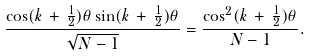<formula> <loc_0><loc_0><loc_500><loc_500>\frac { \cos ( k \, + \, \frac { 1 } { 2 } ) \theta \sin ( k \, + \, \frac { 1 } { 2 } ) \theta } { \sqrt { N - 1 } } = \frac { \cos ^ { 2 } ( k \, + \, \frac { 1 } { 2 } ) \theta } { N - 1 } .</formula> 